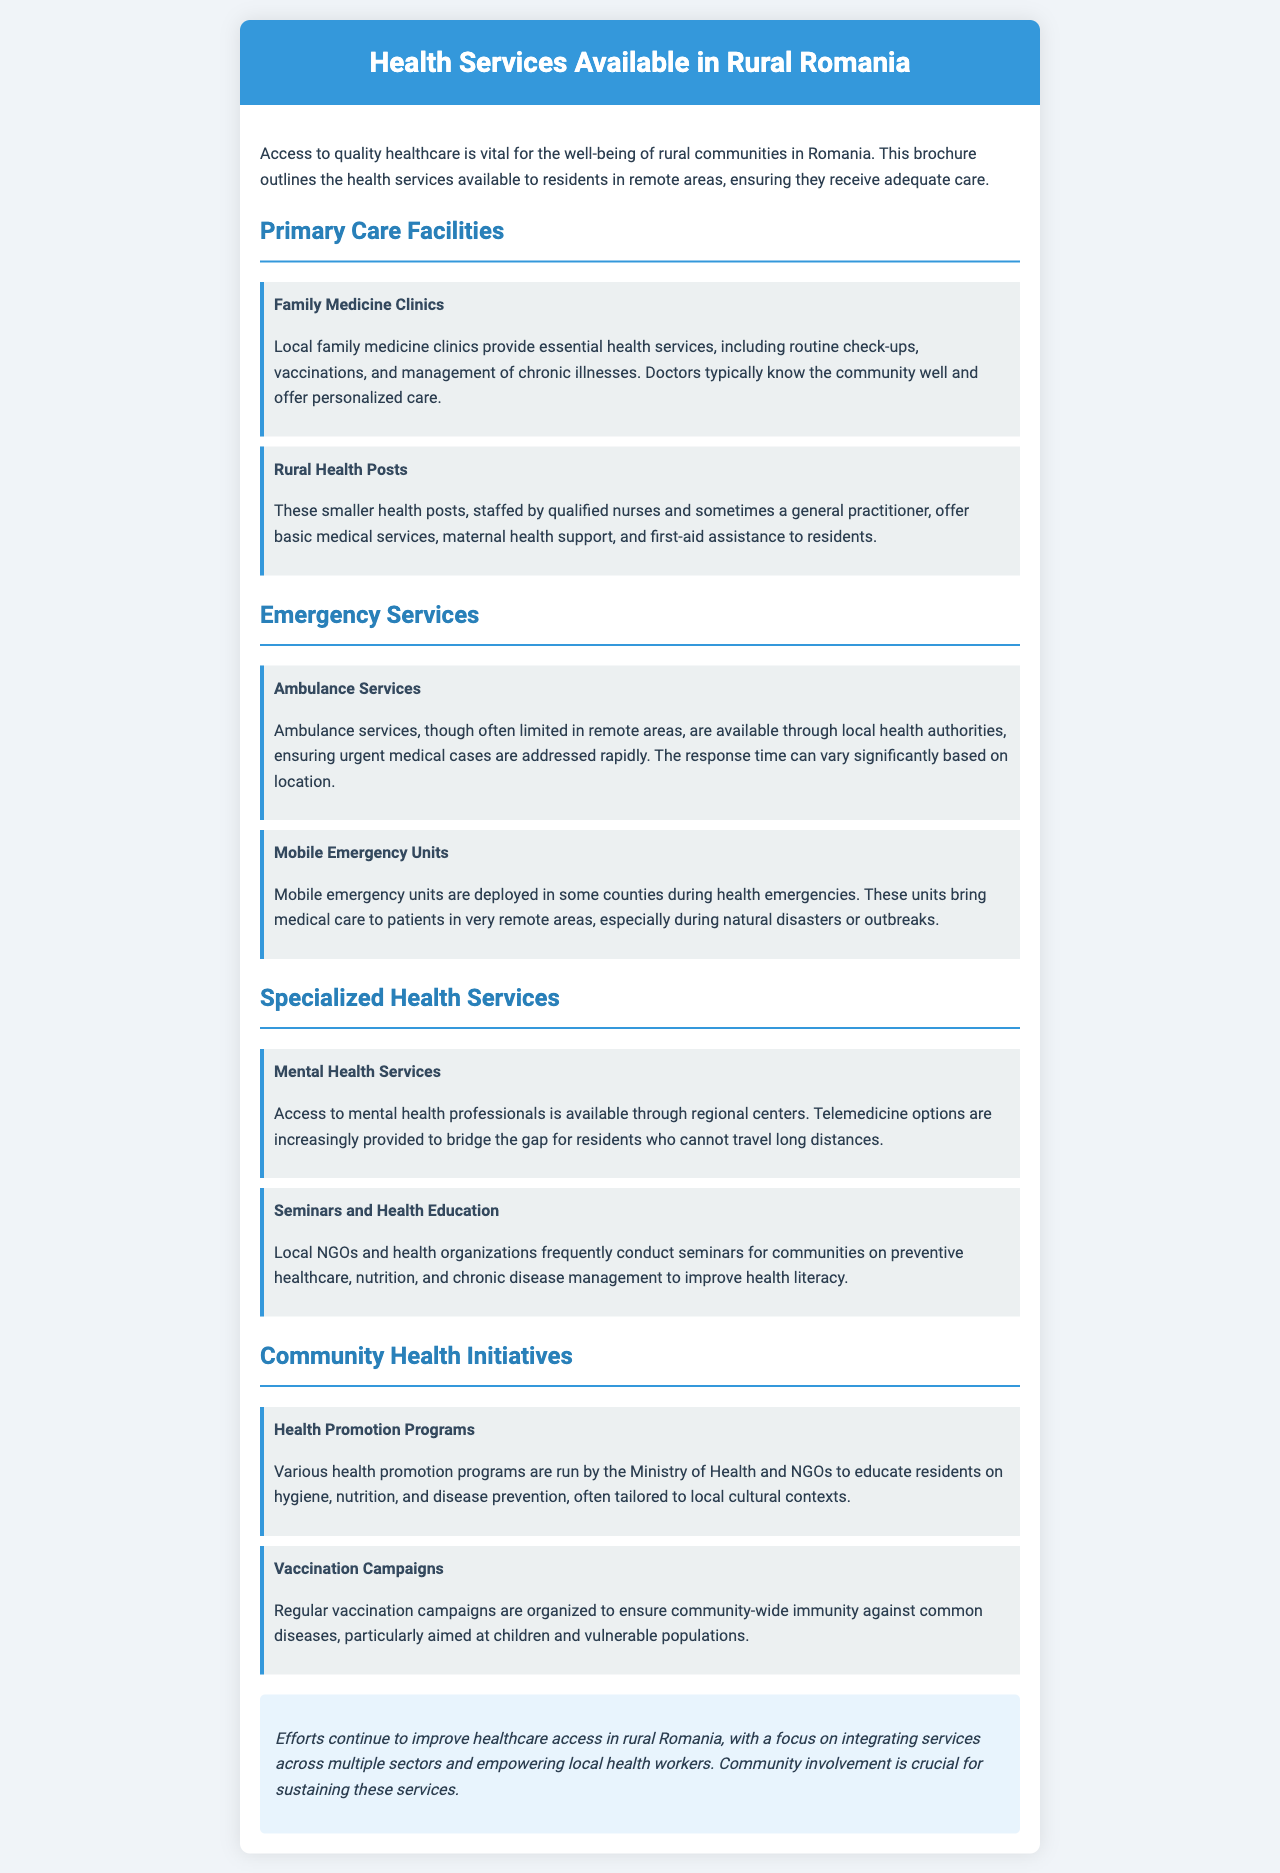What services do family medicine clinics provide? Family medicine clinics provide essential health services, including routine check-ups, vaccinations, and management of chronic illnesses.
Answer: Routine check-ups, vaccinations, management of chronic illnesses Which organization conducts vaccination campaigns? Vaccination campaigns are organized by the Ministry of Health and NGOs.
Answer: Ministry of Health and NGOs What type of support do rural health posts offer? Rural health posts offer basic medical services, maternal health support, and first-aid assistance.
Answer: Basic medical services, maternal health support, first-aid assistance What do mobile emergency units address? Mobile emergency units bring medical care to patients in very remote areas during health emergencies.
Answer: Medical care during health emergencies What is a key focus of health promotion programs? Health promotion programs focus on educating residents on hygiene, nutrition, and disease prevention.
Answer: Educating on hygiene, nutrition, disease prevention How do mental health services increase access? Mental health services use telemedicine options to reach residents who cannot travel long distances.
Answer: Telemedicine options Why are seminars and health education important? Seminars improve health literacy among communities regarding preventive healthcare, nutrition, and chronic disease management.
Answer: Improve health literacy What is emphasized for sustaining health services in rural areas? Community involvement is crucial for sustaining health services in rural areas.
Answer: Community involvement 